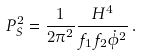<formula> <loc_0><loc_0><loc_500><loc_500>P _ { S } ^ { 2 } = \frac { 1 } { 2 \pi ^ { 2 } } \frac { H ^ { 4 } } { f _ { 1 } f _ { 2 } \dot { \phi } ^ { 2 } } \, .</formula> 